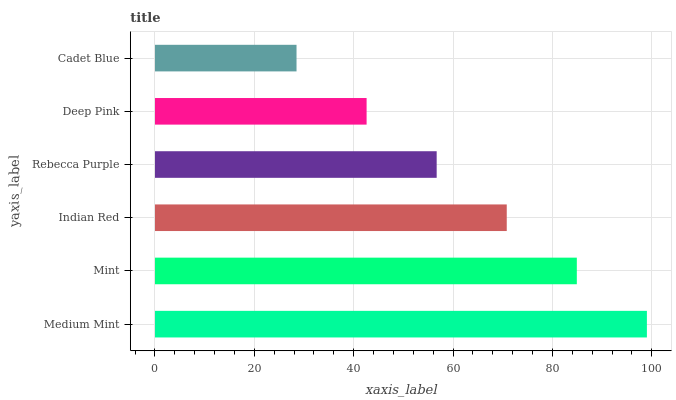Is Cadet Blue the minimum?
Answer yes or no. Yes. Is Medium Mint the maximum?
Answer yes or no. Yes. Is Mint the minimum?
Answer yes or no. No. Is Mint the maximum?
Answer yes or no. No. Is Medium Mint greater than Mint?
Answer yes or no. Yes. Is Mint less than Medium Mint?
Answer yes or no. Yes. Is Mint greater than Medium Mint?
Answer yes or no. No. Is Medium Mint less than Mint?
Answer yes or no. No. Is Indian Red the high median?
Answer yes or no. Yes. Is Rebecca Purple the low median?
Answer yes or no. Yes. Is Deep Pink the high median?
Answer yes or no. No. Is Indian Red the low median?
Answer yes or no. No. 